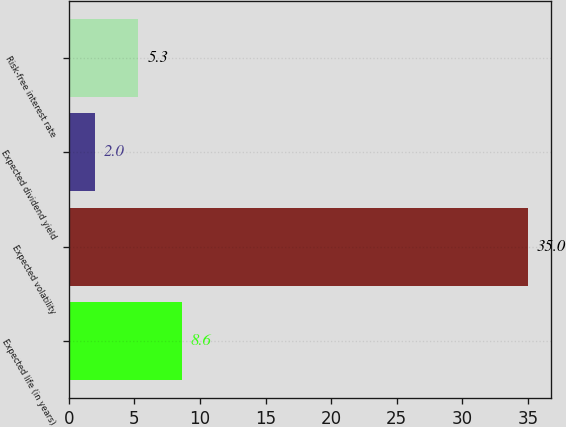<chart> <loc_0><loc_0><loc_500><loc_500><bar_chart><fcel>Expected life (in years)<fcel>Expected volatility<fcel>Expected dividend yield<fcel>Risk-free interest rate<nl><fcel>8.6<fcel>35<fcel>2<fcel>5.3<nl></chart> 